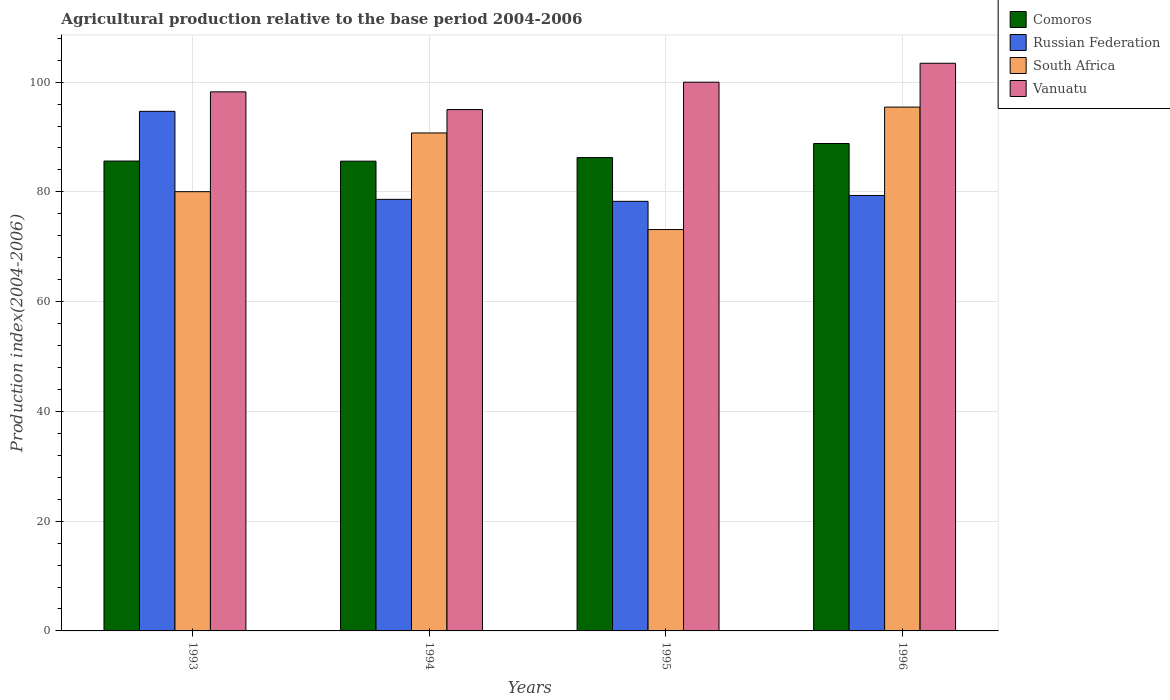How many different coloured bars are there?
Ensure brevity in your answer.  4. How many groups of bars are there?
Offer a very short reply. 4. Are the number of bars per tick equal to the number of legend labels?
Keep it short and to the point. Yes. Are the number of bars on each tick of the X-axis equal?
Offer a terse response. Yes. How many bars are there on the 4th tick from the left?
Offer a terse response. 4. How many bars are there on the 3rd tick from the right?
Keep it short and to the point. 4. What is the label of the 3rd group of bars from the left?
Your response must be concise. 1995. In how many cases, is the number of bars for a given year not equal to the number of legend labels?
Your response must be concise. 0. What is the agricultural production index in Comoros in 1996?
Offer a terse response. 88.82. Across all years, what is the maximum agricultural production index in Russian Federation?
Give a very brief answer. 94.68. Across all years, what is the minimum agricultural production index in South Africa?
Make the answer very short. 73.14. In which year was the agricultural production index in Vanuatu maximum?
Give a very brief answer. 1996. What is the total agricultural production index in South Africa in the graph?
Keep it short and to the point. 339.37. What is the difference between the agricultural production index in Vanuatu in 1994 and that in 1995?
Offer a terse response. -4.99. What is the difference between the agricultural production index in Russian Federation in 1993 and the agricultural production index in South Africa in 1996?
Offer a very short reply. -0.77. What is the average agricultural production index in South Africa per year?
Your response must be concise. 84.84. In the year 1996, what is the difference between the agricultural production index in Russian Federation and agricultural production index in Vanuatu?
Ensure brevity in your answer.  -24.09. In how many years, is the agricultural production index in Russian Federation greater than 12?
Offer a terse response. 4. What is the ratio of the agricultural production index in Comoros in 1995 to that in 1996?
Your answer should be compact. 0.97. Is the agricultural production index in Russian Federation in 1993 less than that in 1994?
Offer a very short reply. No. Is the difference between the agricultural production index in Russian Federation in 1994 and 1996 greater than the difference between the agricultural production index in Vanuatu in 1994 and 1996?
Your answer should be very brief. Yes. What is the difference between the highest and the second highest agricultural production index in Russian Federation?
Your answer should be compact. 15.33. What is the difference between the highest and the lowest agricultural production index in South Africa?
Ensure brevity in your answer.  22.31. In how many years, is the agricultural production index in Vanuatu greater than the average agricultural production index in Vanuatu taken over all years?
Keep it short and to the point. 2. Is the sum of the agricultural production index in South Africa in 1993 and 1994 greater than the maximum agricultural production index in Comoros across all years?
Keep it short and to the point. Yes. Is it the case that in every year, the sum of the agricultural production index in Russian Federation and agricultural production index in South Africa is greater than the sum of agricultural production index in Comoros and agricultural production index in Vanuatu?
Make the answer very short. No. What does the 4th bar from the left in 1993 represents?
Provide a short and direct response. Vanuatu. What does the 4th bar from the right in 1993 represents?
Give a very brief answer. Comoros. Are all the bars in the graph horizontal?
Offer a terse response. No. Does the graph contain any zero values?
Give a very brief answer. No. Does the graph contain grids?
Ensure brevity in your answer.  Yes. How many legend labels are there?
Your answer should be very brief. 4. How are the legend labels stacked?
Offer a very short reply. Vertical. What is the title of the graph?
Your response must be concise. Agricultural production relative to the base period 2004-2006. What is the label or title of the Y-axis?
Provide a short and direct response. Production index(2004-2006). What is the Production index(2004-2006) of Comoros in 1993?
Make the answer very short. 85.62. What is the Production index(2004-2006) in Russian Federation in 1993?
Provide a short and direct response. 94.68. What is the Production index(2004-2006) in South Africa in 1993?
Your answer should be compact. 80.04. What is the Production index(2004-2006) of Vanuatu in 1993?
Your answer should be compact. 98.23. What is the Production index(2004-2006) of Comoros in 1994?
Give a very brief answer. 85.6. What is the Production index(2004-2006) of Russian Federation in 1994?
Give a very brief answer. 78.64. What is the Production index(2004-2006) in South Africa in 1994?
Provide a short and direct response. 90.74. What is the Production index(2004-2006) in Vanuatu in 1994?
Your answer should be compact. 95. What is the Production index(2004-2006) in Comoros in 1995?
Give a very brief answer. 86.25. What is the Production index(2004-2006) of Russian Federation in 1995?
Offer a terse response. 78.28. What is the Production index(2004-2006) in South Africa in 1995?
Offer a terse response. 73.14. What is the Production index(2004-2006) of Vanuatu in 1995?
Your answer should be compact. 99.99. What is the Production index(2004-2006) in Comoros in 1996?
Provide a short and direct response. 88.82. What is the Production index(2004-2006) of Russian Federation in 1996?
Your answer should be very brief. 79.35. What is the Production index(2004-2006) of South Africa in 1996?
Provide a short and direct response. 95.45. What is the Production index(2004-2006) of Vanuatu in 1996?
Offer a terse response. 103.44. Across all years, what is the maximum Production index(2004-2006) of Comoros?
Ensure brevity in your answer.  88.82. Across all years, what is the maximum Production index(2004-2006) in Russian Federation?
Ensure brevity in your answer.  94.68. Across all years, what is the maximum Production index(2004-2006) of South Africa?
Ensure brevity in your answer.  95.45. Across all years, what is the maximum Production index(2004-2006) of Vanuatu?
Your answer should be very brief. 103.44. Across all years, what is the minimum Production index(2004-2006) of Comoros?
Provide a succinct answer. 85.6. Across all years, what is the minimum Production index(2004-2006) of Russian Federation?
Provide a succinct answer. 78.28. Across all years, what is the minimum Production index(2004-2006) of South Africa?
Ensure brevity in your answer.  73.14. Across all years, what is the minimum Production index(2004-2006) of Vanuatu?
Offer a very short reply. 95. What is the total Production index(2004-2006) in Comoros in the graph?
Ensure brevity in your answer.  346.29. What is the total Production index(2004-2006) of Russian Federation in the graph?
Your answer should be compact. 330.95. What is the total Production index(2004-2006) of South Africa in the graph?
Offer a terse response. 339.37. What is the total Production index(2004-2006) of Vanuatu in the graph?
Make the answer very short. 396.66. What is the difference between the Production index(2004-2006) in Comoros in 1993 and that in 1994?
Offer a terse response. 0.02. What is the difference between the Production index(2004-2006) of Russian Federation in 1993 and that in 1994?
Offer a terse response. 16.04. What is the difference between the Production index(2004-2006) of Vanuatu in 1993 and that in 1994?
Your response must be concise. 3.23. What is the difference between the Production index(2004-2006) of Comoros in 1993 and that in 1995?
Your response must be concise. -0.63. What is the difference between the Production index(2004-2006) in Vanuatu in 1993 and that in 1995?
Keep it short and to the point. -1.76. What is the difference between the Production index(2004-2006) of Russian Federation in 1993 and that in 1996?
Provide a succinct answer. 15.33. What is the difference between the Production index(2004-2006) of South Africa in 1993 and that in 1996?
Provide a succinct answer. -15.41. What is the difference between the Production index(2004-2006) in Vanuatu in 1993 and that in 1996?
Your response must be concise. -5.21. What is the difference between the Production index(2004-2006) in Comoros in 1994 and that in 1995?
Ensure brevity in your answer.  -0.65. What is the difference between the Production index(2004-2006) in Russian Federation in 1994 and that in 1995?
Offer a terse response. 0.36. What is the difference between the Production index(2004-2006) of South Africa in 1994 and that in 1995?
Give a very brief answer. 17.6. What is the difference between the Production index(2004-2006) in Vanuatu in 1994 and that in 1995?
Provide a succinct answer. -4.99. What is the difference between the Production index(2004-2006) of Comoros in 1994 and that in 1996?
Your answer should be compact. -3.22. What is the difference between the Production index(2004-2006) of Russian Federation in 1994 and that in 1996?
Give a very brief answer. -0.71. What is the difference between the Production index(2004-2006) of South Africa in 1994 and that in 1996?
Ensure brevity in your answer.  -4.71. What is the difference between the Production index(2004-2006) of Vanuatu in 1994 and that in 1996?
Your answer should be compact. -8.44. What is the difference between the Production index(2004-2006) of Comoros in 1995 and that in 1996?
Make the answer very short. -2.57. What is the difference between the Production index(2004-2006) in Russian Federation in 1995 and that in 1996?
Make the answer very short. -1.07. What is the difference between the Production index(2004-2006) of South Africa in 1995 and that in 1996?
Offer a very short reply. -22.31. What is the difference between the Production index(2004-2006) in Vanuatu in 1995 and that in 1996?
Offer a very short reply. -3.45. What is the difference between the Production index(2004-2006) in Comoros in 1993 and the Production index(2004-2006) in Russian Federation in 1994?
Your answer should be compact. 6.98. What is the difference between the Production index(2004-2006) of Comoros in 1993 and the Production index(2004-2006) of South Africa in 1994?
Offer a very short reply. -5.12. What is the difference between the Production index(2004-2006) of Comoros in 1993 and the Production index(2004-2006) of Vanuatu in 1994?
Offer a terse response. -9.38. What is the difference between the Production index(2004-2006) in Russian Federation in 1993 and the Production index(2004-2006) in South Africa in 1994?
Your answer should be compact. 3.94. What is the difference between the Production index(2004-2006) of Russian Federation in 1993 and the Production index(2004-2006) of Vanuatu in 1994?
Keep it short and to the point. -0.32. What is the difference between the Production index(2004-2006) in South Africa in 1993 and the Production index(2004-2006) in Vanuatu in 1994?
Your answer should be compact. -14.96. What is the difference between the Production index(2004-2006) of Comoros in 1993 and the Production index(2004-2006) of Russian Federation in 1995?
Give a very brief answer. 7.34. What is the difference between the Production index(2004-2006) of Comoros in 1993 and the Production index(2004-2006) of South Africa in 1995?
Provide a succinct answer. 12.48. What is the difference between the Production index(2004-2006) of Comoros in 1993 and the Production index(2004-2006) of Vanuatu in 1995?
Offer a terse response. -14.37. What is the difference between the Production index(2004-2006) in Russian Federation in 1993 and the Production index(2004-2006) in South Africa in 1995?
Keep it short and to the point. 21.54. What is the difference between the Production index(2004-2006) in Russian Federation in 1993 and the Production index(2004-2006) in Vanuatu in 1995?
Keep it short and to the point. -5.31. What is the difference between the Production index(2004-2006) of South Africa in 1993 and the Production index(2004-2006) of Vanuatu in 1995?
Give a very brief answer. -19.95. What is the difference between the Production index(2004-2006) in Comoros in 1993 and the Production index(2004-2006) in Russian Federation in 1996?
Make the answer very short. 6.27. What is the difference between the Production index(2004-2006) in Comoros in 1993 and the Production index(2004-2006) in South Africa in 1996?
Your response must be concise. -9.83. What is the difference between the Production index(2004-2006) in Comoros in 1993 and the Production index(2004-2006) in Vanuatu in 1996?
Your answer should be compact. -17.82. What is the difference between the Production index(2004-2006) of Russian Federation in 1993 and the Production index(2004-2006) of South Africa in 1996?
Keep it short and to the point. -0.77. What is the difference between the Production index(2004-2006) in Russian Federation in 1993 and the Production index(2004-2006) in Vanuatu in 1996?
Ensure brevity in your answer.  -8.76. What is the difference between the Production index(2004-2006) in South Africa in 1993 and the Production index(2004-2006) in Vanuatu in 1996?
Make the answer very short. -23.4. What is the difference between the Production index(2004-2006) of Comoros in 1994 and the Production index(2004-2006) of Russian Federation in 1995?
Offer a terse response. 7.32. What is the difference between the Production index(2004-2006) of Comoros in 1994 and the Production index(2004-2006) of South Africa in 1995?
Offer a terse response. 12.46. What is the difference between the Production index(2004-2006) in Comoros in 1994 and the Production index(2004-2006) in Vanuatu in 1995?
Your response must be concise. -14.39. What is the difference between the Production index(2004-2006) of Russian Federation in 1994 and the Production index(2004-2006) of Vanuatu in 1995?
Make the answer very short. -21.35. What is the difference between the Production index(2004-2006) in South Africa in 1994 and the Production index(2004-2006) in Vanuatu in 1995?
Your answer should be compact. -9.25. What is the difference between the Production index(2004-2006) in Comoros in 1994 and the Production index(2004-2006) in Russian Federation in 1996?
Offer a terse response. 6.25. What is the difference between the Production index(2004-2006) in Comoros in 1994 and the Production index(2004-2006) in South Africa in 1996?
Provide a succinct answer. -9.85. What is the difference between the Production index(2004-2006) in Comoros in 1994 and the Production index(2004-2006) in Vanuatu in 1996?
Offer a very short reply. -17.84. What is the difference between the Production index(2004-2006) of Russian Federation in 1994 and the Production index(2004-2006) of South Africa in 1996?
Offer a very short reply. -16.81. What is the difference between the Production index(2004-2006) in Russian Federation in 1994 and the Production index(2004-2006) in Vanuatu in 1996?
Your answer should be very brief. -24.8. What is the difference between the Production index(2004-2006) in South Africa in 1994 and the Production index(2004-2006) in Vanuatu in 1996?
Give a very brief answer. -12.7. What is the difference between the Production index(2004-2006) of Comoros in 1995 and the Production index(2004-2006) of South Africa in 1996?
Offer a terse response. -9.2. What is the difference between the Production index(2004-2006) of Comoros in 1995 and the Production index(2004-2006) of Vanuatu in 1996?
Offer a terse response. -17.19. What is the difference between the Production index(2004-2006) of Russian Federation in 1995 and the Production index(2004-2006) of South Africa in 1996?
Your answer should be compact. -17.17. What is the difference between the Production index(2004-2006) in Russian Federation in 1995 and the Production index(2004-2006) in Vanuatu in 1996?
Your answer should be compact. -25.16. What is the difference between the Production index(2004-2006) in South Africa in 1995 and the Production index(2004-2006) in Vanuatu in 1996?
Offer a very short reply. -30.3. What is the average Production index(2004-2006) of Comoros per year?
Keep it short and to the point. 86.57. What is the average Production index(2004-2006) of Russian Federation per year?
Your answer should be very brief. 82.74. What is the average Production index(2004-2006) of South Africa per year?
Offer a terse response. 84.84. What is the average Production index(2004-2006) of Vanuatu per year?
Provide a succinct answer. 99.17. In the year 1993, what is the difference between the Production index(2004-2006) in Comoros and Production index(2004-2006) in Russian Federation?
Your answer should be very brief. -9.06. In the year 1993, what is the difference between the Production index(2004-2006) of Comoros and Production index(2004-2006) of South Africa?
Keep it short and to the point. 5.58. In the year 1993, what is the difference between the Production index(2004-2006) in Comoros and Production index(2004-2006) in Vanuatu?
Keep it short and to the point. -12.61. In the year 1993, what is the difference between the Production index(2004-2006) in Russian Federation and Production index(2004-2006) in South Africa?
Keep it short and to the point. 14.64. In the year 1993, what is the difference between the Production index(2004-2006) of Russian Federation and Production index(2004-2006) of Vanuatu?
Ensure brevity in your answer.  -3.55. In the year 1993, what is the difference between the Production index(2004-2006) in South Africa and Production index(2004-2006) in Vanuatu?
Your answer should be compact. -18.19. In the year 1994, what is the difference between the Production index(2004-2006) of Comoros and Production index(2004-2006) of Russian Federation?
Provide a short and direct response. 6.96. In the year 1994, what is the difference between the Production index(2004-2006) of Comoros and Production index(2004-2006) of South Africa?
Give a very brief answer. -5.14. In the year 1994, what is the difference between the Production index(2004-2006) of Russian Federation and Production index(2004-2006) of South Africa?
Offer a terse response. -12.1. In the year 1994, what is the difference between the Production index(2004-2006) in Russian Federation and Production index(2004-2006) in Vanuatu?
Your answer should be very brief. -16.36. In the year 1994, what is the difference between the Production index(2004-2006) of South Africa and Production index(2004-2006) of Vanuatu?
Your response must be concise. -4.26. In the year 1995, what is the difference between the Production index(2004-2006) in Comoros and Production index(2004-2006) in Russian Federation?
Your response must be concise. 7.97. In the year 1995, what is the difference between the Production index(2004-2006) in Comoros and Production index(2004-2006) in South Africa?
Your answer should be compact. 13.11. In the year 1995, what is the difference between the Production index(2004-2006) of Comoros and Production index(2004-2006) of Vanuatu?
Ensure brevity in your answer.  -13.74. In the year 1995, what is the difference between the Production index(2004-2006) in Russian Federation and Production index(2004-2006) in South Africa?
Your answer should be compact. 5.14. In the year 1995, what is the difference between the Production index(2004-2006) of Russian Federation and Production index(2004-2006) of Vanuatu?
Your response must be concise. -21.71. In the year 1995, what is the difference between the Production index(2004-2006) of South Africa and Production index(2004-2006) of Vanuatu?
Provide a short and direct response. -26.85. In the year 1996, what is the difference between the Production index(2004-2006) of Comoros and Production index(2004-2006) of Russian Federation?
Keep it short and to the point. 9.47. In the year 1996, what is the difference between the Production index(2004-2006) in Comoros and Production index(2004-2006) in South Africa?
Your answer should be compact. -6.63. In the year 1996, what is the difference between the Production index(2004-2006) in Comoros and Production index(2004-2006) in Vanuatu?
Your response must be concise. -14.62. In the year 1996, what is the difference between the Production index(2004-2006) of Russian Federation and Production index(2004-2006) of South Africa?
Give a very brief answer. -16.1. In the year 1996, what is the difference between the Production index(2004-2006) of Russian Federation and Production index(2004-2006) of Vanuatu?
Give a very brief answer. -24.09. In the year 1996, what is the difference between the Production index(2004-2006) of South Africa and Production index(2004-2006) of Vanuatu?
Offer a very short reply. -7.99. What is the ratio of the Production index(2004-2006) in Comoros in 1993 to that in 1994?
Your response must be concise. 1. What is the ratio of the Production index(2004-2006) in Russian Federation in 1993 to that in 1994?
Your answer should be very brief. 1.2. What is the ratio of the Production index(2004-2006) of South Africa in 1993 to that in 1994?
Your response must be concise. 0.88. What is the ratio of the Production index(2004-2006) of Vanuatu in 1993 to that in 1994?
Provide a short and direct response. 1.03. What is the ratio of the Production index(2004-2006) of Russian Federation in 1993 to that in 1995?
Your response must be concise. 1.21. What is the ratio of the Production index(2004-2006) in South Africa in 1993 to that in 1995?
Offer a very short reply. 1.09. What is the ratio of the Production index(2004-2006) of Vanuatu in 1993 to that in 1995?
Provide a succinct answer. 0.98. What is the ratio of the Production index(2004-2006) of Comoros in 1993 to that in 1996?
Provide a succinct answer. 0.96. What is the ratio of the Production index(2004-2006) of Russian Federation in 1993 to that in 1996?
Offer a terse response. 1.19. What is the ratio of the Production index(2004-2006) of South Africa in 1993 to that in 1996?
Ensure brevity in your answer.  0.84. What is the ratio of the Production index(2004-2006) of Vanuatu in 1993 to that in 1996?
Make the answer very short. 0.95. What is the ratio of the Production index(2004-2006) of South Africa in 1994 to that in 1995?
Ensure brevity in your answer.  1.24. What is the ratio of the Production index(2004-2006) in Vanuatu in 1994 to that in 1995?
Provide a short and direct response. 0.95. What is the ratio of the Production index(2004-2006) in Comoros in 1994 to that in 1996?
Your answer should be very brief. 0.96. What is the ratio of the Production index(2004-2006) of South Africa in 1994 to that in 1996?
Provide a succinct answer. 0.95. What is the ratio of the Production index(2004-2006) in Vanuatu in 1994 to that in 1996?
Ensure brevity in your answer.  0.92. What is the ratio of the Production index(2004-2006) in Comoros in 1995 to that in 1996?
Your answer should be very brief. 0.97. What is the ratio of the Production index(2004-2006) of Russian Federation in 1995 to that in 1996?
Give a very brief answer. 0.99. What is the ratio of the Production index(2004-2006) in South Africa in 1995 to that in 1996?
Your response must be concise. 0.77. What is the ratio of the Production index(2004-2006) of Vanuatu in 1995 to that in 1996?
Offer a very short reply. 0.97. What is the difference between the highest and the second highest Production index(2004-2006) of Comoros?
Offer a very short reply. 2.57. What is the difference between the highest and the second highest Production index(2004-2006) of Russian Federation?
Offer a terse response. 15.33. What is the difference between the highest and the second highest Production index(2004-2006) in South Africa?
Offer a very short reply. 4.71. What is the difference between the highest and the second highest Production index(2004-2006) of Vanuatu?
Make the answer very short. 3.45. What is the difference between the highest and the lowest Production index(2004-2006) of Comoros?
Make the answer very short. 3.22. What is the difference between the highest and the lowest Production index(2004-2006) of South Africa?
Provide a succinct answer. 22.31. What is the difference between the highest and the lowest Production index(2004-2006) of Vanuatu?
Ensure brevity in your answer.  8.44. 